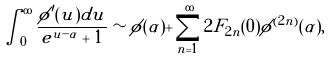Convert formula to latex. <formula><loc_0><loc_0><loc_500><loc_500>\int _ { 0 } ^ { \infty } \frac { \phi ^ { \prime } ( u ) d u } { e ^ { u - \alpha } + 1 } \sim \phi ( \alpha ) + \sum _ { n = 1 } ^ { \infty } 2 F _ { 2 n } ( 0 ) \phi ^ { ( 2 n ) } ( \alpha ) ,</formula> 